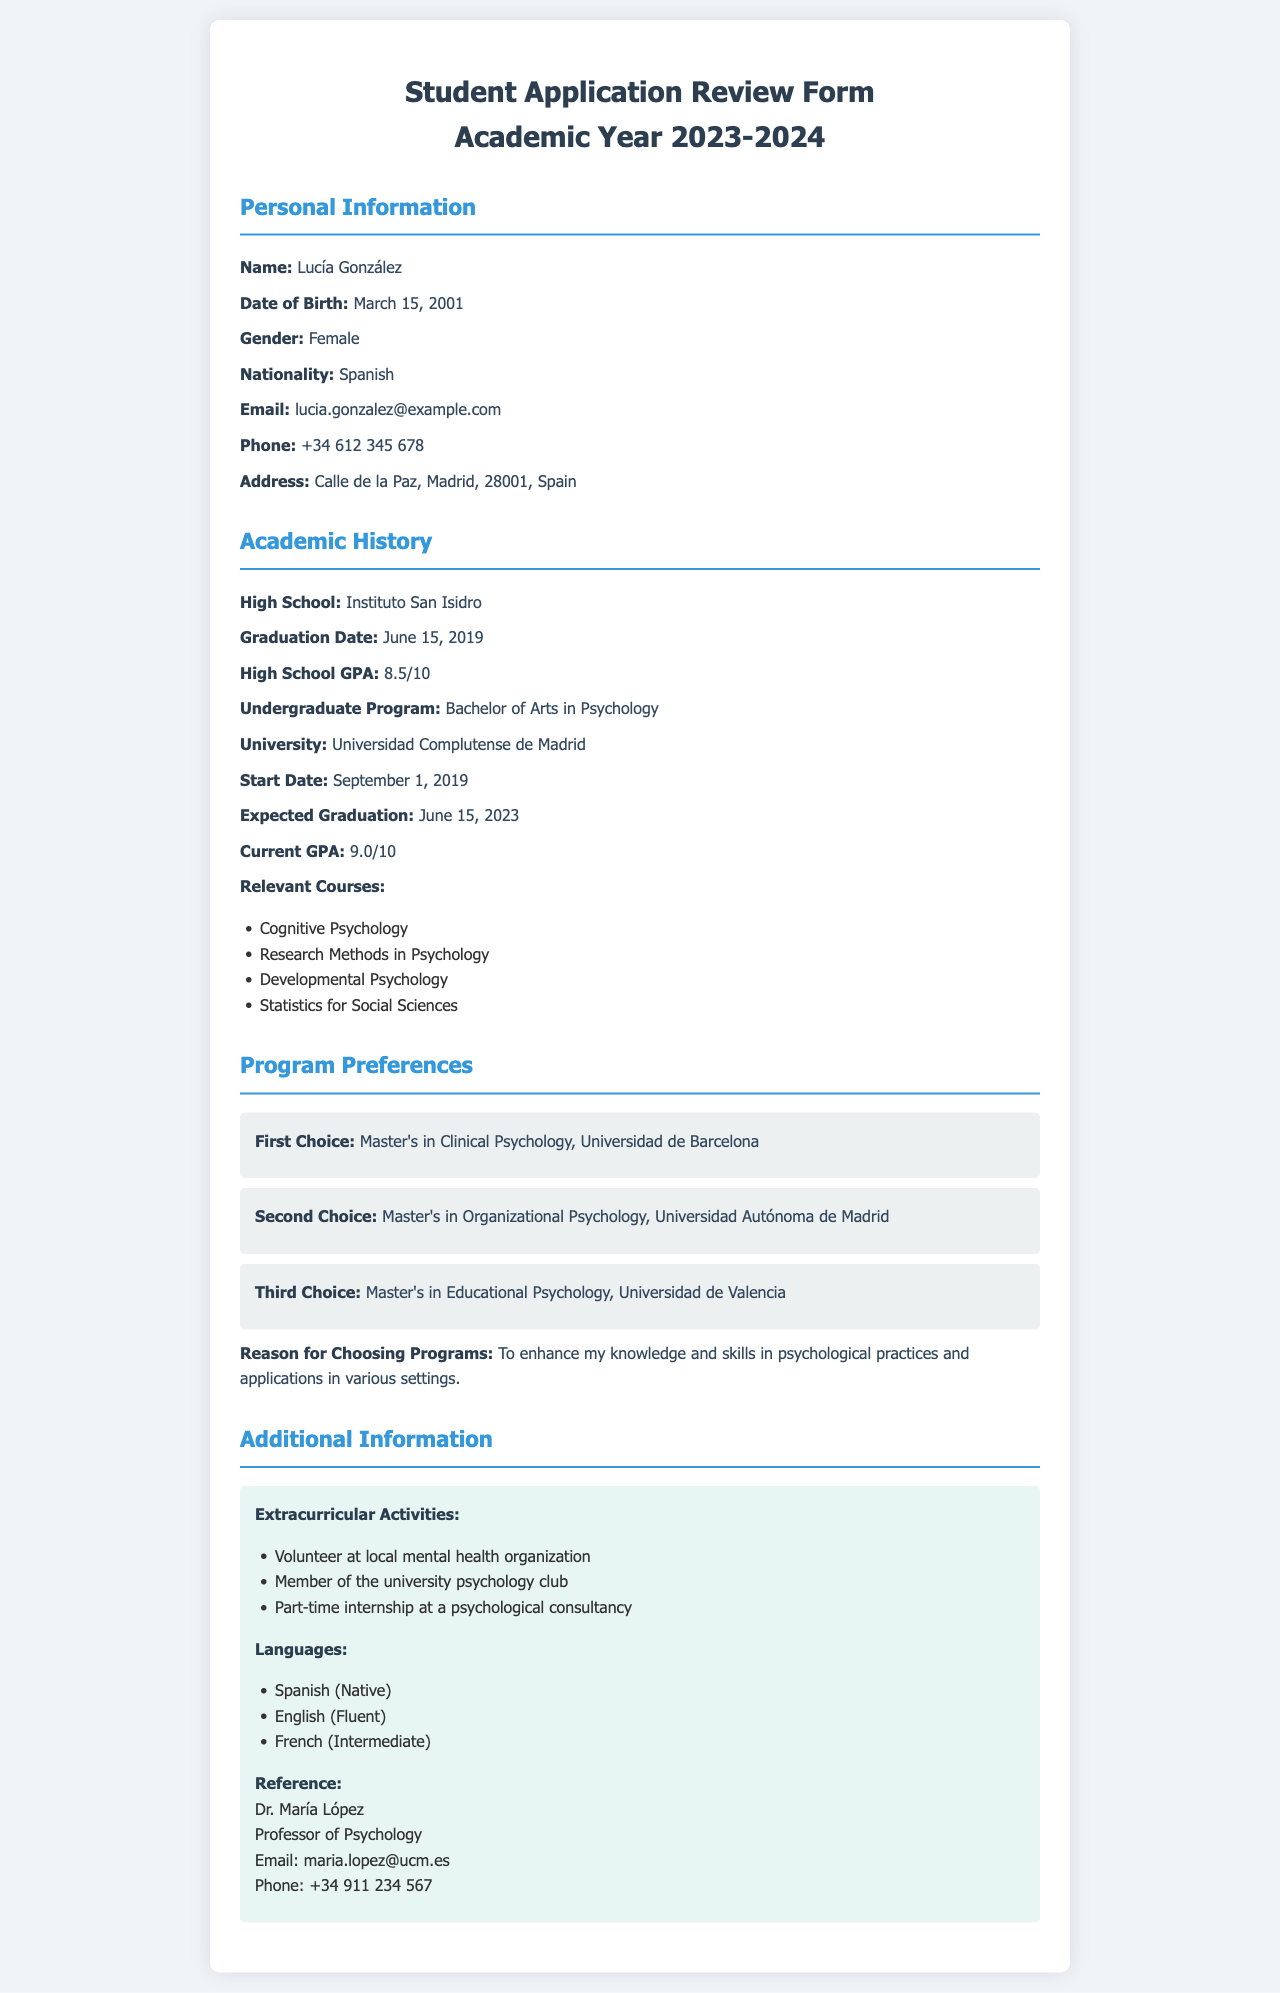What is the applicant's name? The name of the applicant is listed in the personal information section of the document.
Answer: Lucía González What is the applicant's current GPA? The current GPA is provided under the Academic History section.
Answer: 9.0/10 What is the graduation date from high school? The graduation date from high school can be found in the Academic History section.
Answer: June 15, 2019 What program is listed as the applicant's first choice? The first choice program is detailed in the Program Preferences section.
Answer: Master's in Clinical Psychology, Universidad de Barcelona What extracurricular activity is mentioned? Several extracurricular activities are listed under the Additional Information section.
Answer: Volunteer at local mental health organization What language proficiency level does the applicant have in French? The language proficiency levels are specified in the Additional Information section.
Answer: Intermediate How many relevant courses are listed under Academic History? The number of relevant courses is counted from the list provided in the Academic History section.
Answer: 4 What is the reason for choosing the programs? The reason for choosing the programs is included in the Program Preferences section.
Answer: To enhance my knowledge and skills in psychological practices and applications in various settings Which university did the applicant attend for their undergraduate program? The university name for undergraduate studies is provided in the Academic History section.
Answer: Universidad Complutense de Madrid 